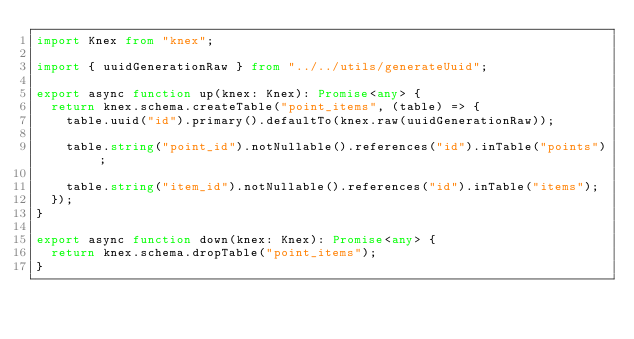<code> <loc_0><loc_0><loc_500><loc_500><_TypeScript_>import Knex from "knex";

import { uuidGenerationRaw } from "../../utils/generateUuid";

export async function up(knex: Knex): Promise<any> {
  return knex.schema.createTable("point_items", (table) => {
    table.uuid("id").primary().defaultTo(knex.raw(uuidGenerationRaw));

    table.string("point_id").notNullable().references("id").inTable("points");

    table.string("item_id").notNullable().references("id").inTable("items");
  });
}

export async function down(knex: Knex): Promise<any> {
  return knex.schema.dropTable("point_items");
}
</code> 